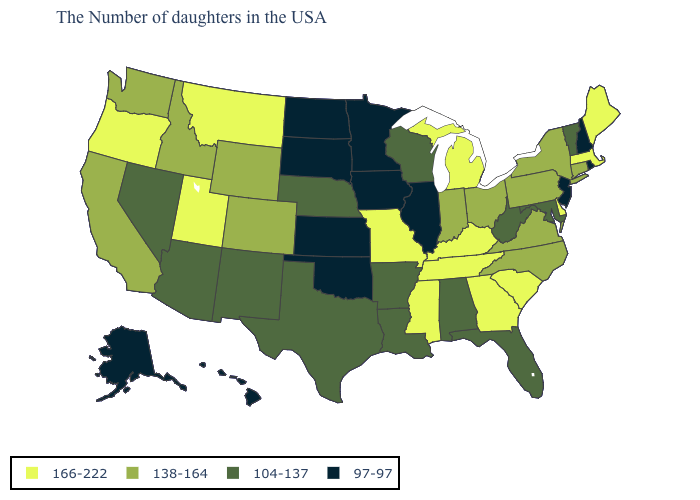What is the highest value in the USA?
Short answer required. 166-222. Name the states that have a value in the range 97-97?
Answer briefly. Rhode Island, New Hampshire, New Jersey, Illinois, Minnesota, Iowa, Kansas, Oklahoma, South Dakota, North Dakota, Alaska, Hawaii. Which states have the lowest value in the USA?
Answer briefly. Rhode Island, New Hampshire, New Jersey, Illinois, Minnesota, Iowa, Kansas, Oklahoma, South Dakota, North Dakota, Alaska, Hawaii. What is the value of Pennsylvania?
Write a very short answer. 138-164. Which states hav the highest value in the MidWest?
Answer briefly. Michigan, Missouri. Does North Dakota have the lowest value in the MidWest?
Short answer required. Yes. Name the states that have a value in the range 166-222?
Quick response, please. Maine, Massachusetts, Delaware, South Carolina, Georgia, Michigan, Kentucky, Tennessee, Mississippi, Missouri, Utah, Montana, Oregon. Among the states that border South Carolina , which have the lowest value?
Answer briefly. North Carolina. Among the states that border Montana , does Wyoming have the lowest value?
Concise answer only. No. Name the states that have a value in the range 104-137?
Be succinct. Vermont, Maryland, West Virginia, Florida, Alabama, Wisconsin, Louisiana, Arkansas, Nebraska, Texas, New Mexico, Arizona, Nevada. Which states have the lowest value in the West?
Give a very brief answer. Alaska, Hawaii. Does Rhode Island have the same value as Wisconsin?
Give a very brief answer. No. Name the states that have a value in the range 138-164?
Write a very short answer. Connecticut, New York, Pennsylvania, Virginia, North Carolina, Ohio, Indiana, Wyoming, Colorado, Idaho, California, Washington. Does Florida have the lowest value in the USA?
Answer briefly. No. 